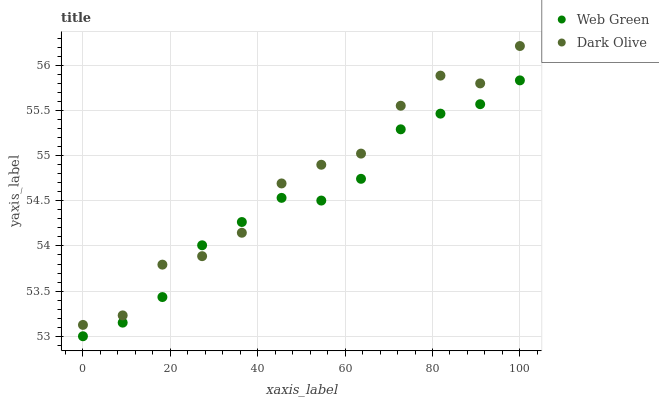Does Web Green have the minimum area under the curve?
Answer yes or no. Yes. Does Dark Olive have the maximum area under the curve?
Answer yes or no. Yes. Does Web Green have the maximum area under the curve?
Answer yes or no. No. Is Web Green the smoothest?
Answer yes or no. Yes. Is Dark Olive the roughest?
Answer yes or no. Yes. Is Web Green the roughest?
Answer yes or no. No. Does Web Green have the lowest value?
Answer yes or no. Yes. Does Dark Olive have the highest value?
Answer yes or no. Yes. Does Web Green have the highest value?
Answer yes or no. No. Does Web Green intersect Dark Olive?
Answer yes or no. Yes. Is Web Green less than Dark Olive?
Answer yes or no. No. Is Web Green greater than Dark Olive?
Answer yes or no. No. 